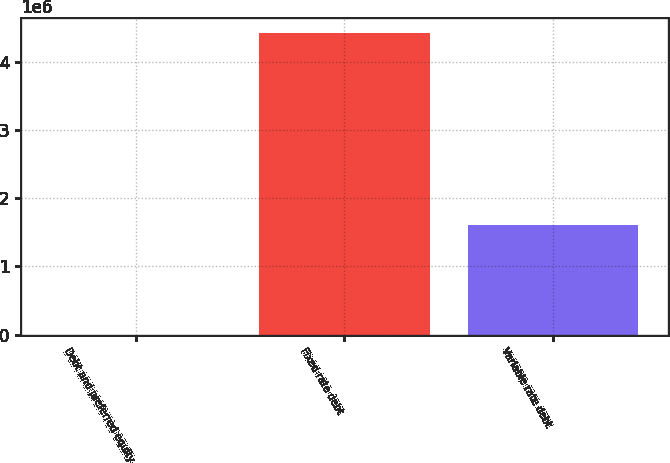Convert chart. <chart><loc_0><loc_0><loc_500><loc_500><bar_chart><fcel>Debt and preferred equity<fcel>Fixed rate debt<fcel>Variable rate debt<nl><fcel>2<fcel>4.42187e+06<fcel>1.61222e+06<nl></chart> 